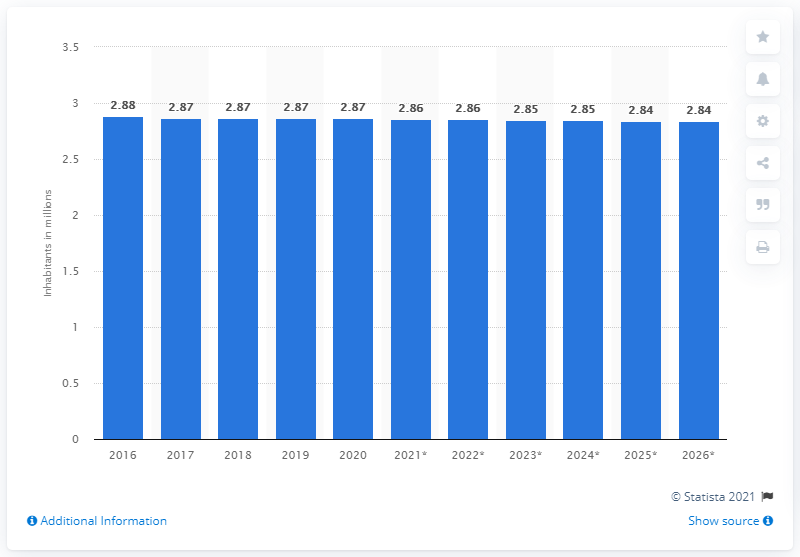Indicate a few pertinent items in this graphic. In 2020, the population of Albania was 2.85 million. 